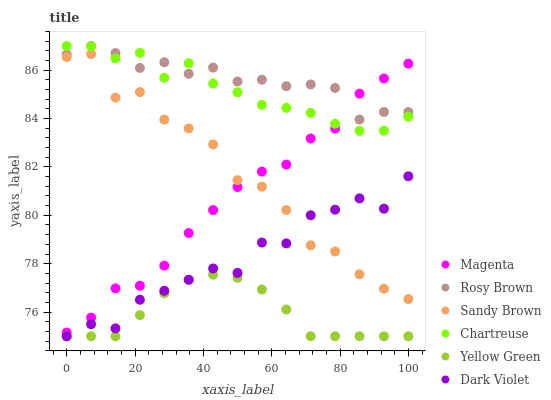Does Yellow Green have the minimum area under the curve?
Answer yes or no. Yes. Does Rosy Brown have the maximum area under the curve?
Answer yes or no. Yes. Does Dark Violet have the minimum area under the curve?
Answer yes or no. No. Does Dark Violet have the maximum area under the curve?
Answer yes or no. No. Is Yellow Green the smoothest?
Answer yes or no. Yes. Is Sandy Brown the roughest?
Answer yes or no. Yes. Is Rosy Brown the smoothest?
Answer yes or no. No. Is Rosy Brown the roughest?
Answer yes or no. No. Does Yellow Green have the lowest value?
Answer yes or no. Yes. Does Rosy Brown have the lowest value?
Answer yes or no. No. Does Chartreuse have the highest value?
Answer yes or no. Yes. Does Dark Violet have the highest value?
Answer yes or no. No. Is Yellow Green less than Chartreuse?
Answer yes or no. Yes. Is Chartreuse greater than Yellow Green?
Answer yes or no. Yes. Does Sandy Brown intersect Magenta?
Answer yes or no. Yes. Is Sandy Brown less than Magenta?
Answer yes or no. No. Is Sandy Brown greater than Magenta?
Answer yes or no. No. Does Yellow Green intersect Chartreuse?
Answer yes or no. No. 